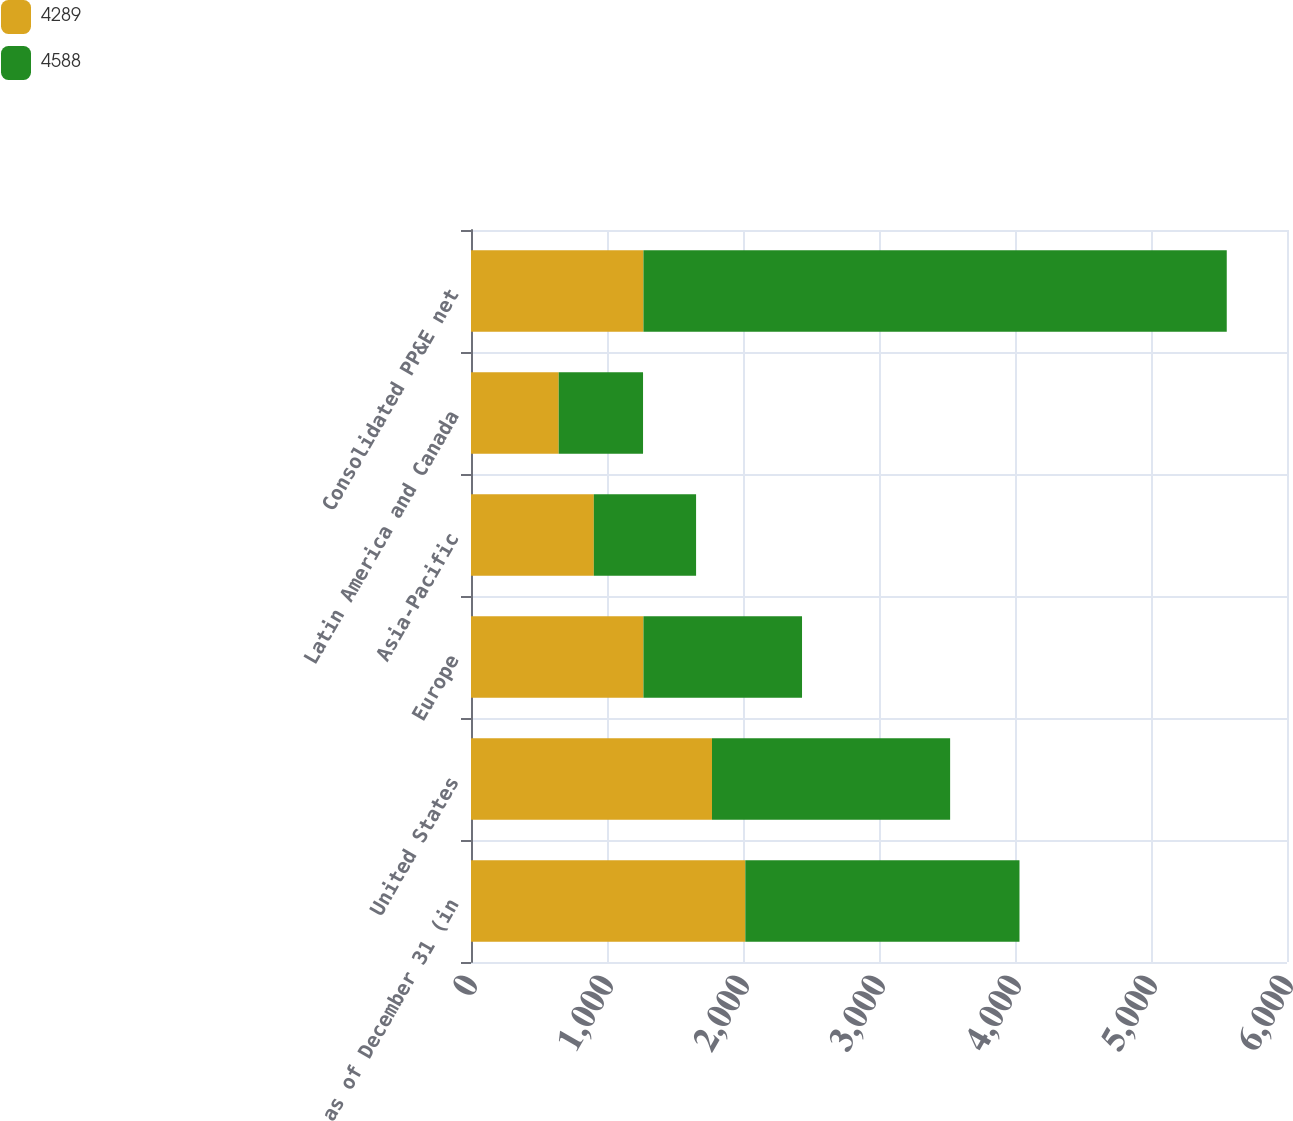Convert chart. <chart><loc_0><loc_0><loc_500><loc_500><stacked_bar_chart><ecel><fcel>as of December 31 (in<fcel>United States<fcel>Europe<fcel>Asia-Pacific<fcel>Latin America and Canada<fcel>Consolidated PP&E net<nl><fcel>4289<fcel>2017<fcel>1772<fcel>1268<fcel>903<fcel>645<fcel>1268<nl><fcel>4588<fcel>2016<fcel>1751<fcel>1166<fcel>752<fcel>620<fcel>4289<nl></chart> 